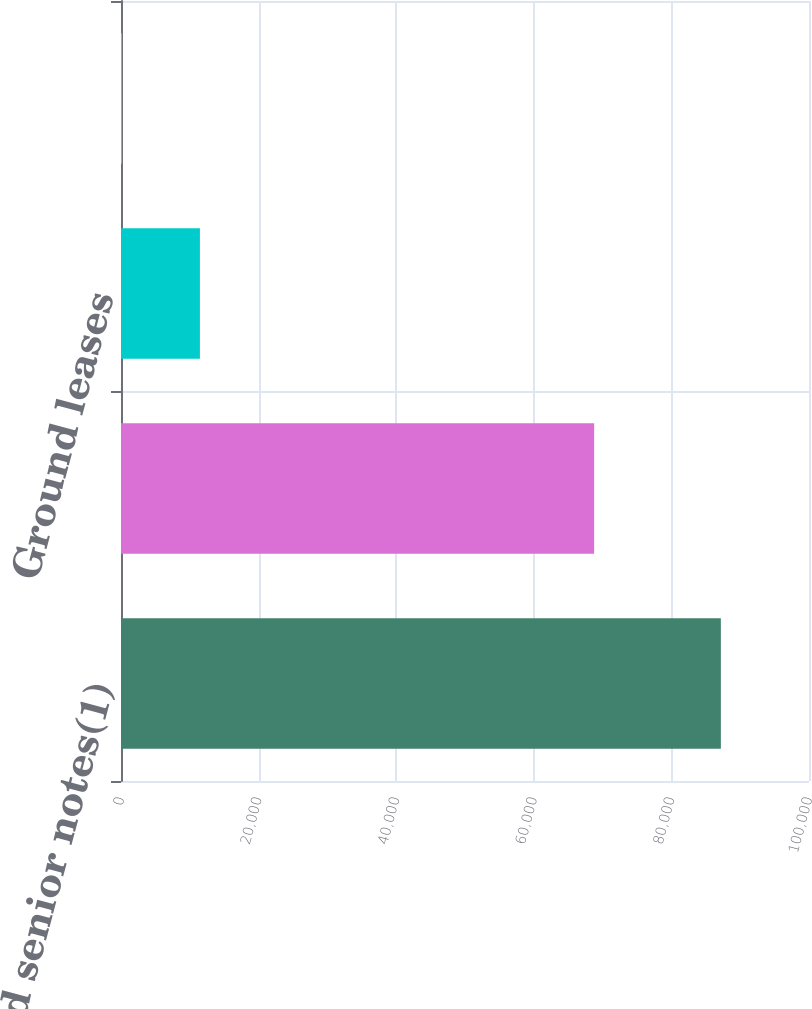Convert chart. <chart><loc_0><loc_0><loc_500><loc_500><bar_chart><fcel>Unsecured senior notes(1)<fcel>Exchangeable senior notes(1)<fcel>Ground leases<fcel>Other Obligations(3)<nl><fcel>87188<fcel>68769<fcel>11471<fcel>116<nl></chart> 